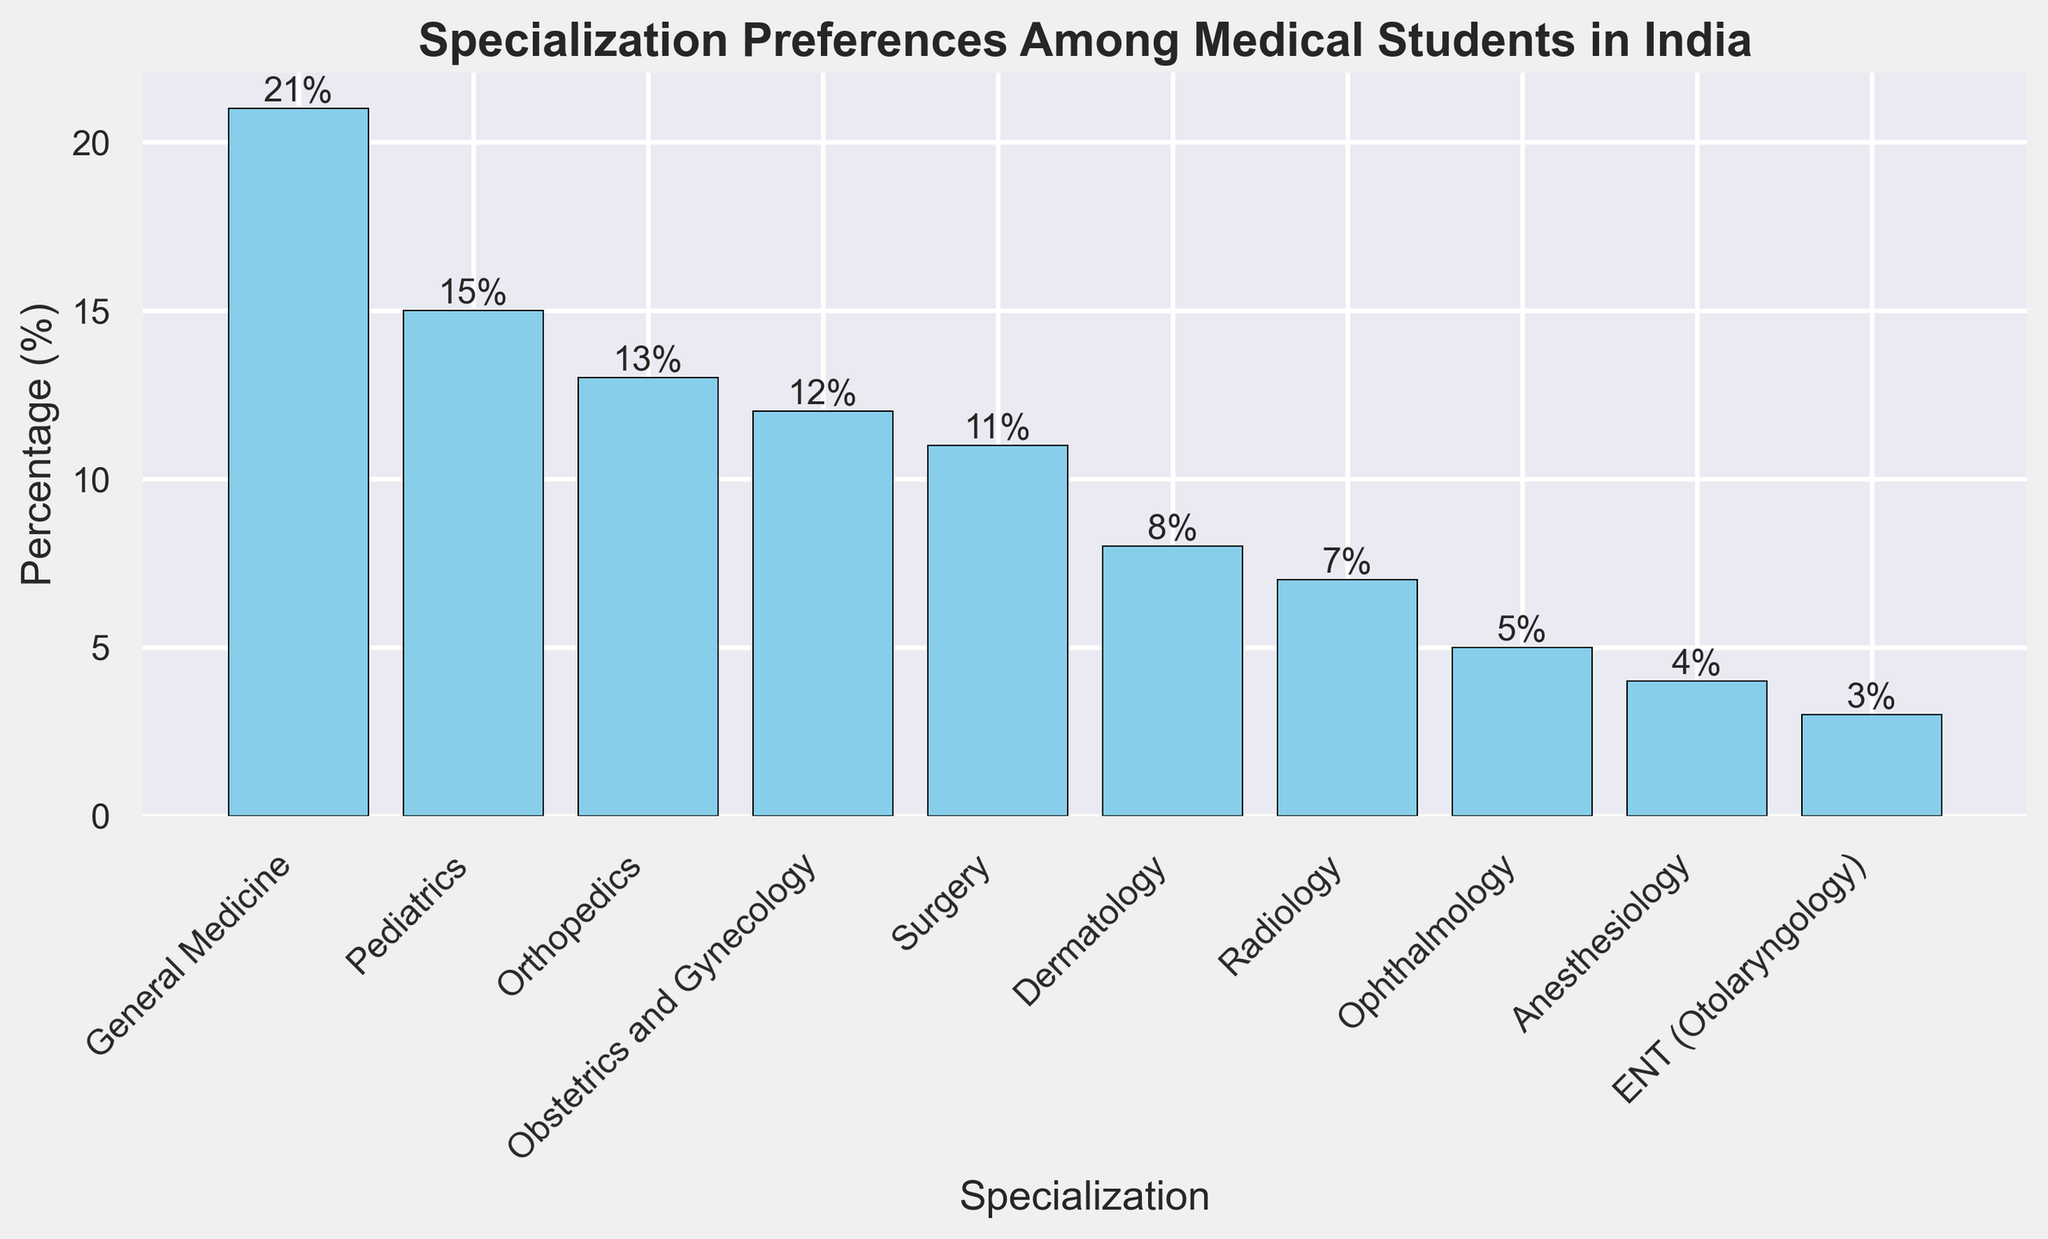What is the most preferred specialization among medical students in India? By looking at the bar chart, the specialization with the tallest bar is the most preferred. The tallest bar represents General Medicine with a percentage of 21%.
Answer: General Medicine Which specialization is the least preferred? The shortest bar in the bar chart indicates the least preferred specialization. The shortest bar corresponds to ENT (Otolaryngology) with a percentage of 3%.
Answer: ENT (Otolaryngology) How much more preferred is General Medicine compared to Ophthalmology? To find how much more General Medicine is preferred compared to Ophthalmology, subtract the percentage for Ophthalmology from General Medicine. The percentages are 21% for General Medicine and 5% for Ophthalmology. 21% - 5% = 16%.
Answer: 16% Which specializations have exactly 4% and 5% preference respectively? The bar chart shows that Anesthesiology has 4%, and Ophthalmology has 5% preference among medical students.
Answer: Anesthesiology and Ophthalmology What is the combined percentage of students preferring Radiology and Dermatology? To find the combined percentage, sum the percentages of Radiology and Dermatology. Radiology has 7% while Dermatology has 8%. 7% + 8% = 15%.
Answer: 15% How many specializations have preferences greater than 10%? By counting the bars whose heights represent percentages greater than 10, we find that there are five such specializations: General Medicine (21%), Pediatrics (15%), Orthopedics (13%), Obstetrics and Gynecology (12%), and Surgery (11%).
Answer: 5 Are there any specializations with the same preference percentage? By examining the bar chart, we can see that no two specializations share the same height, so no two specializations have the same preference percentage.
Answer: No What is the average preference percentage of the top three specializations? The top three specializations are General Medicine (21%), Pediatrics (15%), and Orthopedics (13%). To get the average: (21% + 15% + 13%) / 3 = 49% / 3 ≈ 16.33%.
Answer: 16.33% Which specialization has the closest preference percentage to 10%? By identifying the bar closest to a height that represents 10%, Surgery is closest with a percentage of 11%.
Answer: Surgery 